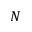Convert formula to latex. <formula><loc_0><loc_0><loc_500><loc_500>N</formula> 